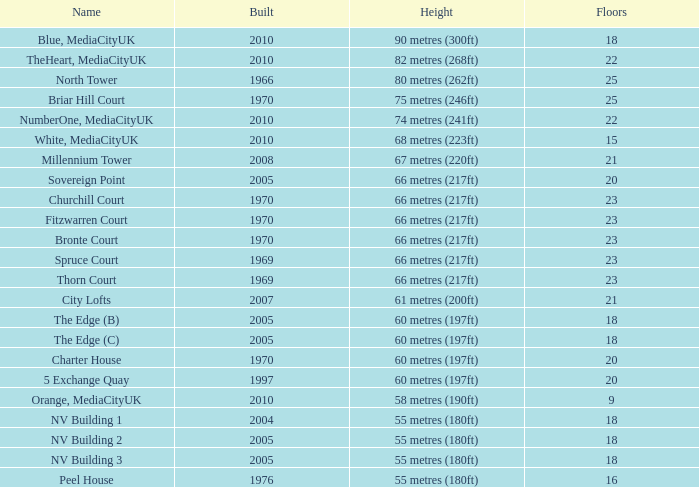What is the elevation, when position is under 20, when levels is over 9, when constructed is 2005, and when title is the edge (c)? 60 metres (197ft). 